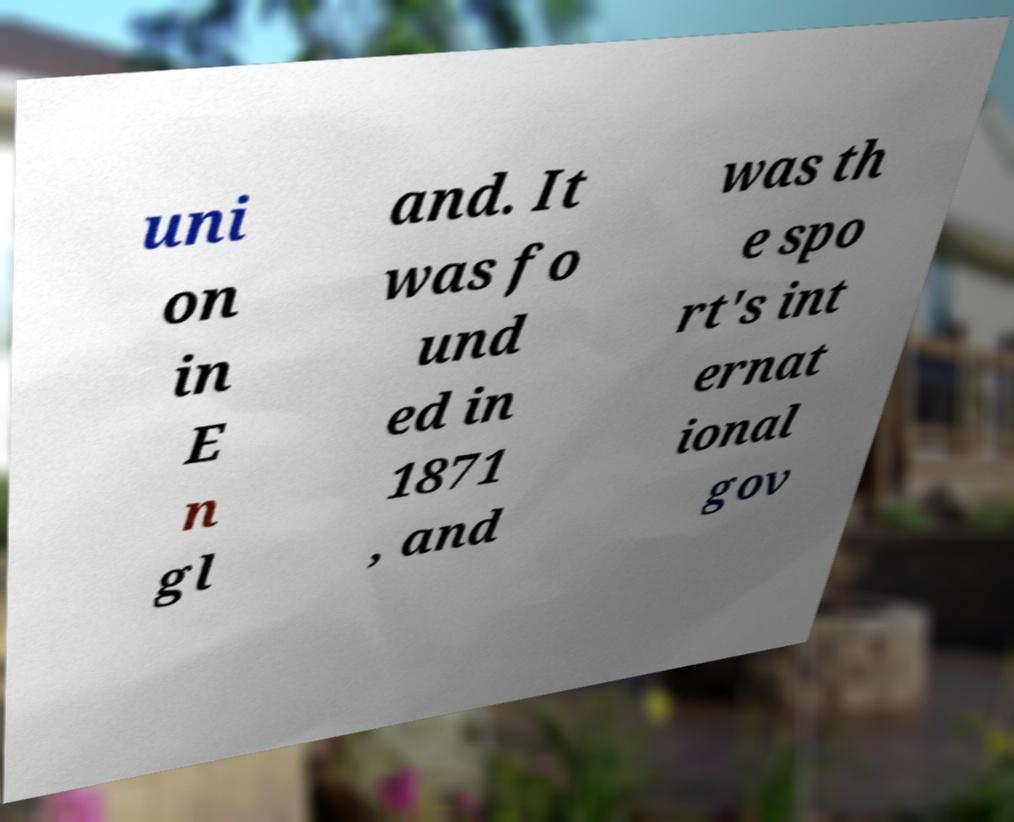Can you read and provide the text displayed in the image?This photo seems to have some interesting text. Can you extract and type it out for me? uni on in E n gl and. It was fo und ed in 1871 , and was th e spo rt's int ernat ional gov 